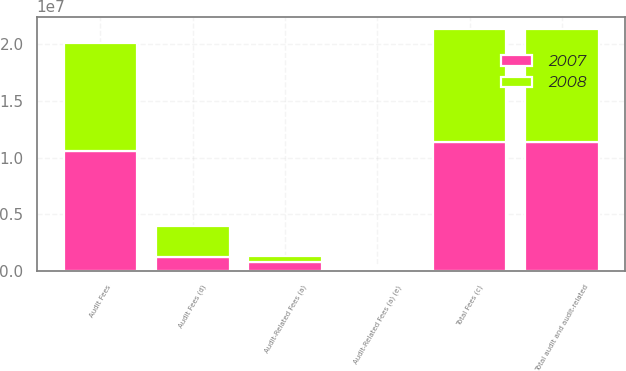<chart> <loc_0><loc_0><loc_500><loc_500><stacked_bar_chart><ecel><fcel>Audit Fees<fcel>Audit-Related Fees (a)<fcel>Total audit and audit-related<fcel>Total Fees (c)<fcel>Audit Fees (d)<fcel>Audit-Related Fees (a) (e)<nl><fcel>2007<fcel>1.05872e+07<fcel>778689<fcel>1.13658e+07<fcel>1.13658e+07<fcel>1.23259e+06<fcel>200000<nl><fcel>2008<fcel>9.51224e+06<fcel>507851<fcel>1.00201e+07<fcel>1.00315e+07<fcel>2.753e+06<fcel>112000<nl></chart> 